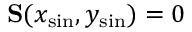Convert formula to latex. <formula><loc_0><loc_0><loc_500><loc_500>S ( x _ { \sin } , y _ { \sin } ) = 0</formula> 